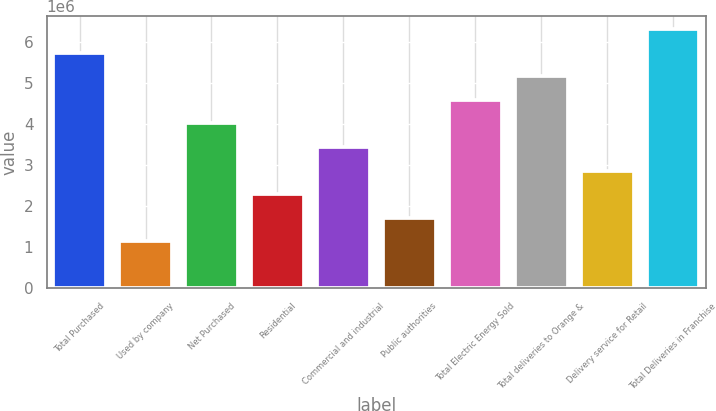Convert chart. <chart><loc_0><loc_0><loc_500><loc_500><bar_chart><fcel>Total Purchased<fcel>Used by company<fcel>Net Purchased<fcel>Residential<fcel>Commercial and industrial<fcel>Public authorities<fcel>Total Electric Energy Sold<fcel>Total deliveries to Orange &<fcel>Delivery service for Retail<fcel>Total Deliveries in Franchise<nl><fcel>5.74255e+06<fcel>1.14852e+06<fcel>4.01979e+06<fcel>2.29703e+06<fcel>3.44554e+06<fcel>1.72277e+06<fcel>4.59405e+06<fcel>5.1683e+06<fcel>2.87128e+06<fcel>6.31681e+06<nl></chart> 